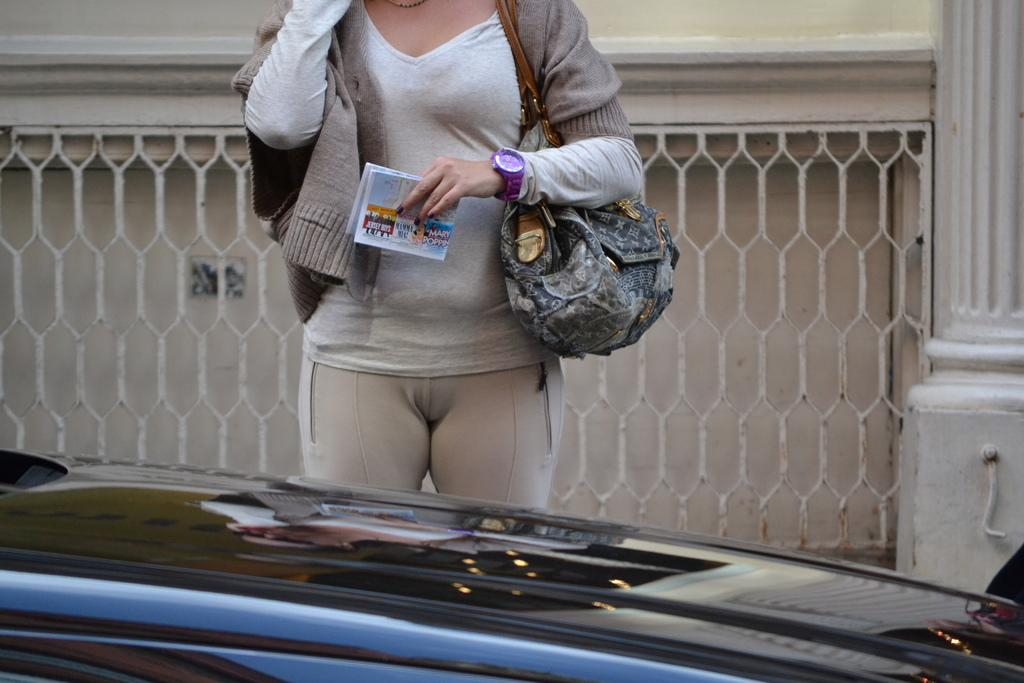Who is the main subject in the image? There is a lady in the image. What is the lady holding in her hand? The lady is holding a paper in her hand. What else is the lady holding? The lady is holding a handbag. What can be seen behind the lady? There is a black colored car in the image, and the lady is standing in front of it. What other elements are visible in the background of the image? There is a grill and a wall in the background of the image. What type of grass is growing on the lady's head in the image? There is no grass visible on the lady's head in the image. What kind of wound can be seen on the lady's arm in the image? There is no wound visible on the lady's arm in the image. What crime is being committed in the image? There is no crime being committed in the image. 